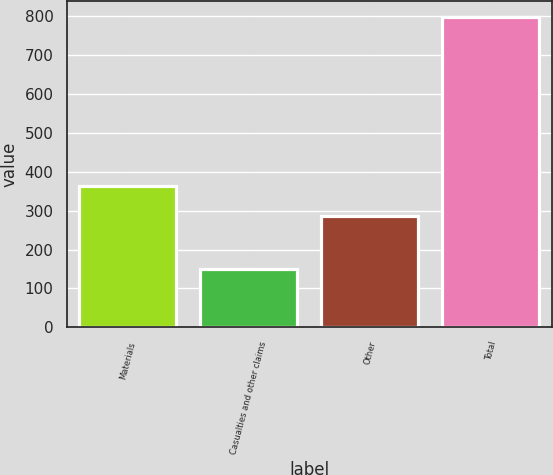Convert chart to OTSL. <chart><loc_0><loc_0><loc_500><loc_500><bar_chart><fcel>Materials<fcel>Casualties and other claims<fcel>Other<fcel>Total<nl><fcel>364<fcel>150<fcel>285<fcel>799<nl></chart> 